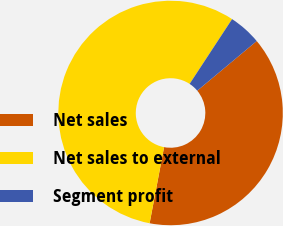Convert chart to OTSL. <chart><loc_0><loc_0><loc_500><loc_500><pie_chart><fcel>Net sales<fcel>Net sales to external<fcel>Segment profit<nl><fcel>39.06%<fcel>56.25%<fcel>4.69%<nl></chart> 